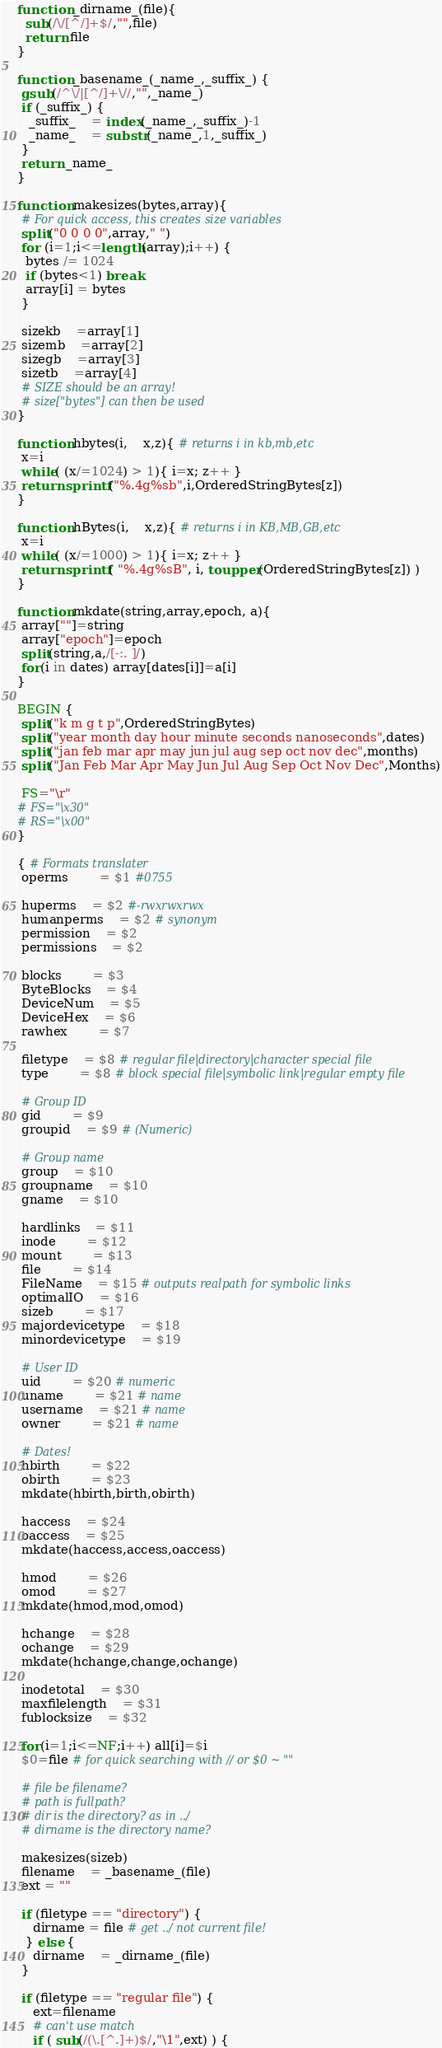<code> <loc_0><loc_0><loc_500><loc_500><_Awk_>
function _dirname_(file){ 
  sub(/\/[^/]+$/,"",file)
  return file
}

function _basename_(_name_,_suffix_) {
 gsub(/^\/|[^/]+\//,"",_name_)
 if (_suffix_) {
   _suffix_	= index(_name_,_suffix_)-1
   _name_	= substr(_name_,1,_suffix_)
 }
 return _name_
}

function makesizes(bytes,array){
 # For quick access, this creates size variables
 split("0 0 0 0",array," ")
 for (i=1;i<=length(array);i++) {
  bytes /= 1024
  if (bytes<1) break
  array[i] = bytes
 }

 sizekb	=array[1]
 sizemb	=array[2]
 sizegb	=array[3]
 sizetb	=array[4]
 # SIZE should be an array!
 # size["bytes"] can then be used
}

function hbytes(i,	x,z){ # returns i in kb,mb,etc
 x=i
 while( (x/=1024) > 1){ i=x; z++ }
 return sprintf("%.4g%sb",i,OrderedStringBytes[z])
}

function hBytes(i,	x,z){ # returns i in KB,MB,GB,etc
 x=i
 while( (x/=1000) > 1){ i=x; z++ }
 return sprintf( "%.4g%sB", i, toupper(OrderedStringBytes[z]) )
}

function mkdate(string,array,epoch, a){
 array[""]=string
 array["epoch"]=epoch
 split(string,a,/[-:. ]/)
 for(i in dates) array[dates[i]]=a[i]
}

BEGIN {
 split("k m g t p",OrderedStringBytes)
 split("year month day hour minute seconds nanoseconds",dates)
 split("jan feb mar apr may jun jul aug sep oct nov dec",months)
 split("Jan Feb Mar Apr May Jun Jul Aug Sep Oct Nov Dec",Months)

 FS="\r"
# FS="\x30"
# RS="\x00"
}

{ # Formats translater
 operms		= $1 #0755 

 huperms	= $2 #-rwxrwxrwx
 humanperms	= $2 # synonym
 permission	= $2
 permissions	= $2
 
 blocks		= $3
 ByteBlocks	= $4
 DeviceNum	= $5
 DeviceHex	= $6
 rawhex		= $7

 filetype	= $8 # regular file|directory|character special file
 type		= $8 # block special file|symbolic link|regular empty file

 # Group ID
 gid		= $9 
 groupid	= $9 # (Numeric)

 # Group name
 group	= $10
 groupname	= $10
 gname	= $10

 hardlinks	= $11
 inode		= $12
 mount		= $13
 file		= $14
 FileName	= $15 # outputs realpath for symbolic links
 optimalIO	= $16
 sizeb		= $17
 majordevicetype	= $18
 minordevicetype	= $19

 # User ID
 uid		= $20 # numeric
 uname		= $21 # name
 username	= $21 # name
 owner		= $21 # name

 # Dates!
 hbirth		= $22
 obirth		= $23
 mkdate(hbirth,birth,obirth)
 
 haccess	= $24
 oaccess	= $25
 mkdate(haccess,access,oaccess)
 
 hmod		= $26
 omod		= $27
 mkdate(hmod,mod,omod)
 
 hchange	= $28
 ochange	= $29
 mkdate(hchange,change,ochange)
 
 inodetotal	= $30
 maxfilelength	= $31
 fublocksize	= $32

 for(i=1;i<=NF;i++) all[i]=$i
 $0=file # for quick searching with // or $0 ~ ""

 # file be filename?
 # path is fullpath?
 # dir is the directory? as in ../
 # dirname is the directory name?
 
 makesizes(sizeb)
 filename	= _basename_(file)
 ext = ""

 if (filetype == "directory") {
	dirname = file # get ../ not current file!
  } else {
	dirname	= _dirname_(file)
 }

 if (filetype == "regular file") {
	ext=filename
	# can't use match
	if ( sub(/(\.[^.]+)$/,"\1",ext) ) {</code> 